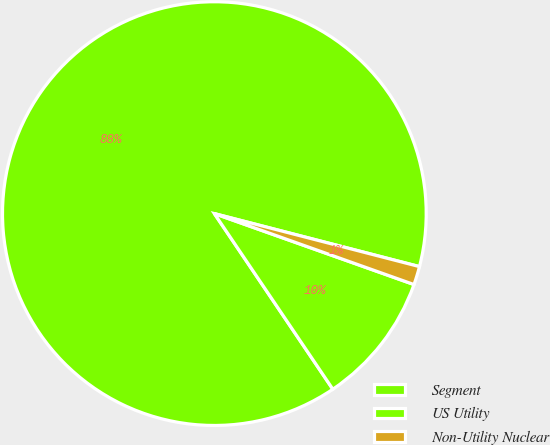Convert chart. <chart><loc_0><loc_0><loc_500><loc_500><pie_chart><fcel>Segment<fcel>US Utility<fcel>Non-Utility Nuclear<nl><fcel>88.47%<fcel>10.12%<fcel>1.41%<nl></chart> 